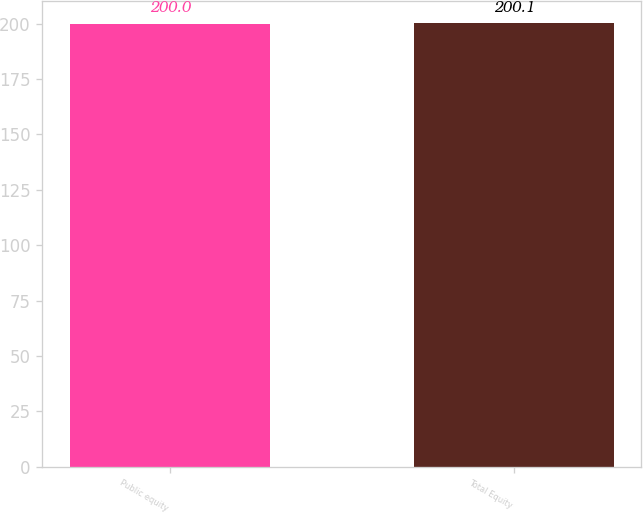<chart> <loc_0><loc_0><loc_500><loc_500><bar_chart><fcel>Public equity<fcel>Total Equity<nl><fcel>200<fcel>200.1<nl></chart> 